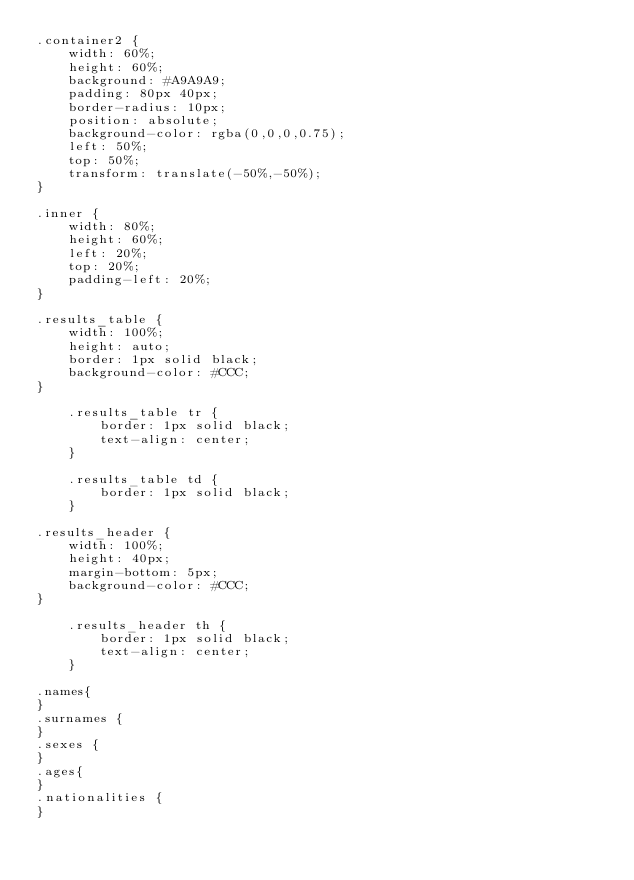Convert code to text. <code><loc_0><loc_0><loc_500><loc_500><_CSS_>.container2 {
    width: 60%;
    height: 60%;
    background: #A9A9A9;
    padding: 80px 40px;
    border-radius: 10px;
    position: absolute;
    background-color: rgba(0,0,0,0.75);
    left: 50%;
    top: 50%;
    transform: translate(-50%,-50%);
}

.inner {
    width: 80%;
    height: 60%;
    left: 20%;
    top: 20%;
    padding-left: 20%;
}

.results_table {
    width: 100%;
    height: auto;
    border: 1px solid black;
    background-color: #CCC;
}

    .results_table tr {
        border: 1px solid black;
        text-align: center;
    }

    .results_table td {
        border: 1px solid black;
    }

.results_header {
    width: 100%;
    height: 40px;
    margin-bottom: 5px;
    background-color: #CCC;
}

    .results_header th {
        border: 1px solid black;
        text-align: center;
    }

.names{
}
.surnames {
}
.sexes {
}
.ages{
}
.nationalities {
}
</code> 